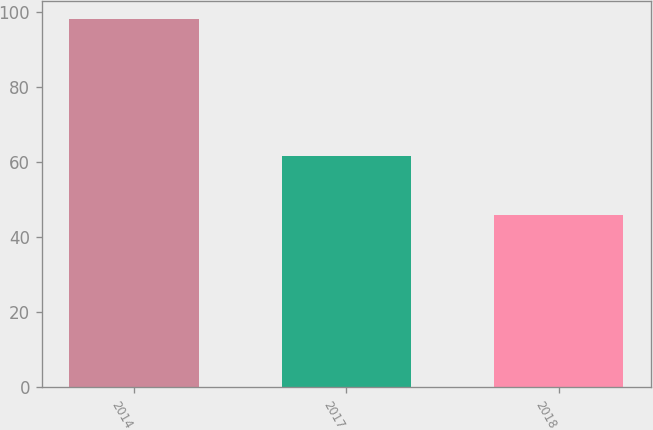<chart> <loc_0><loc_0><loc_500><loc_500><bar_chart><fcel>2014<fcel>2017<fcel>2018<nl><fcel>98<fcel>61.6<fcel>45.8<nl></chart> 